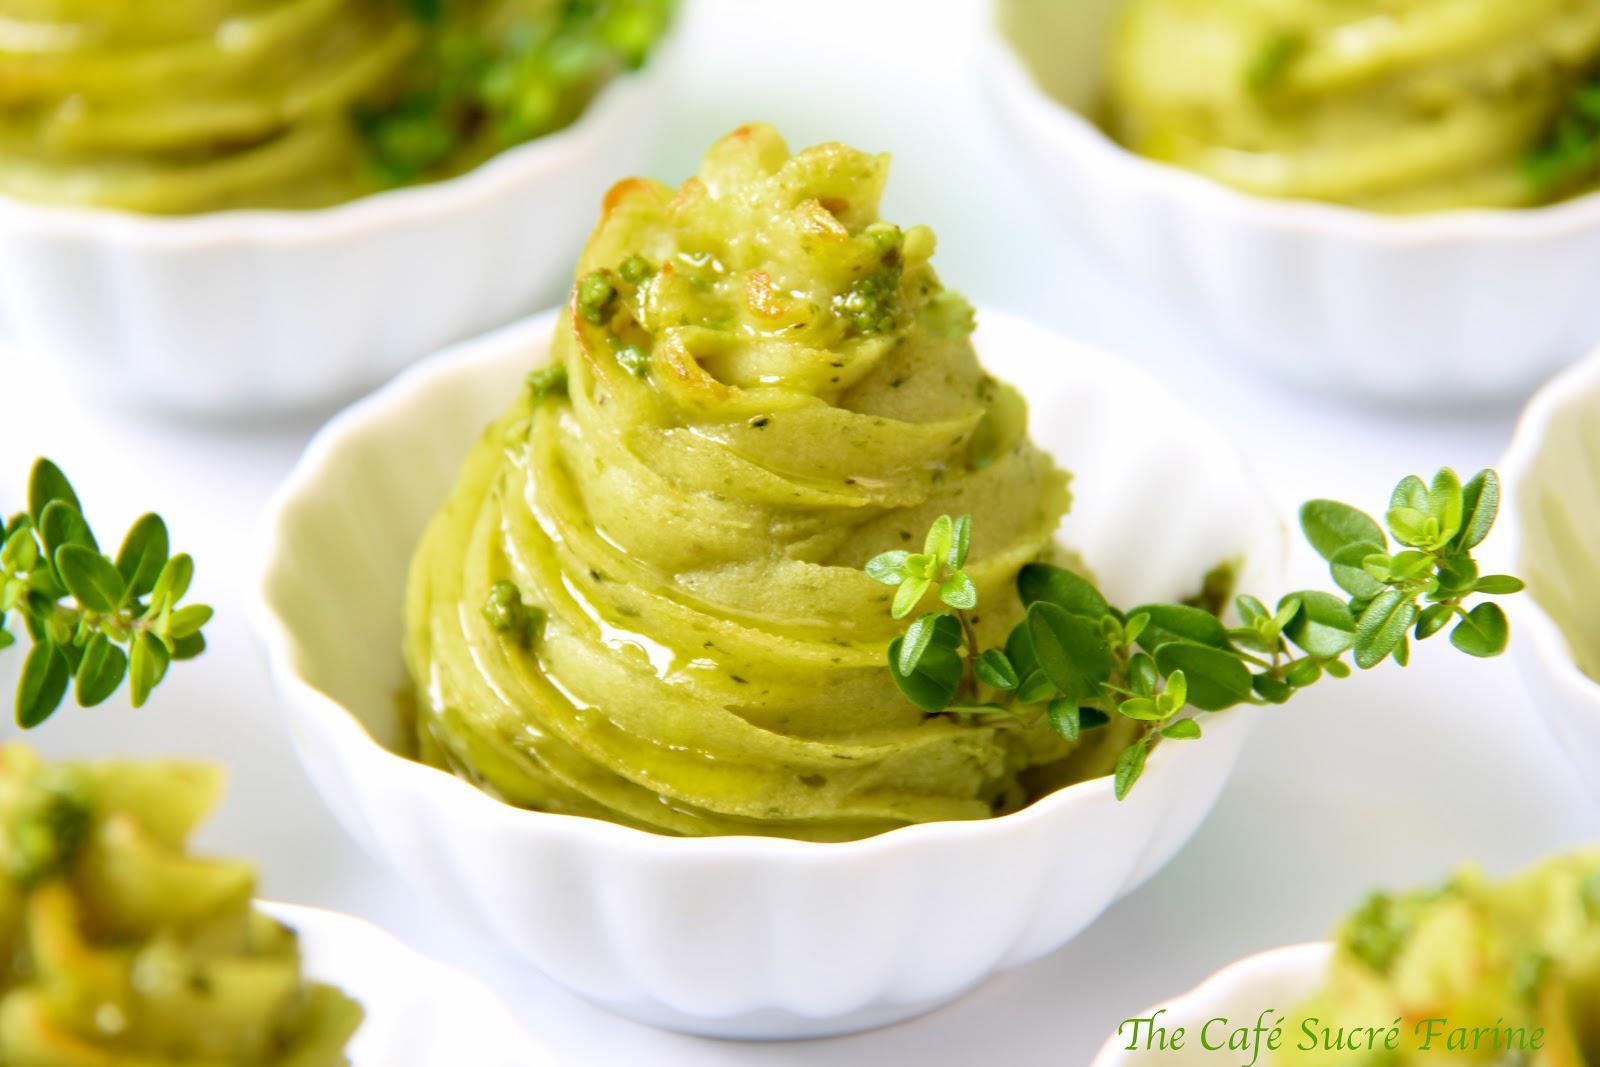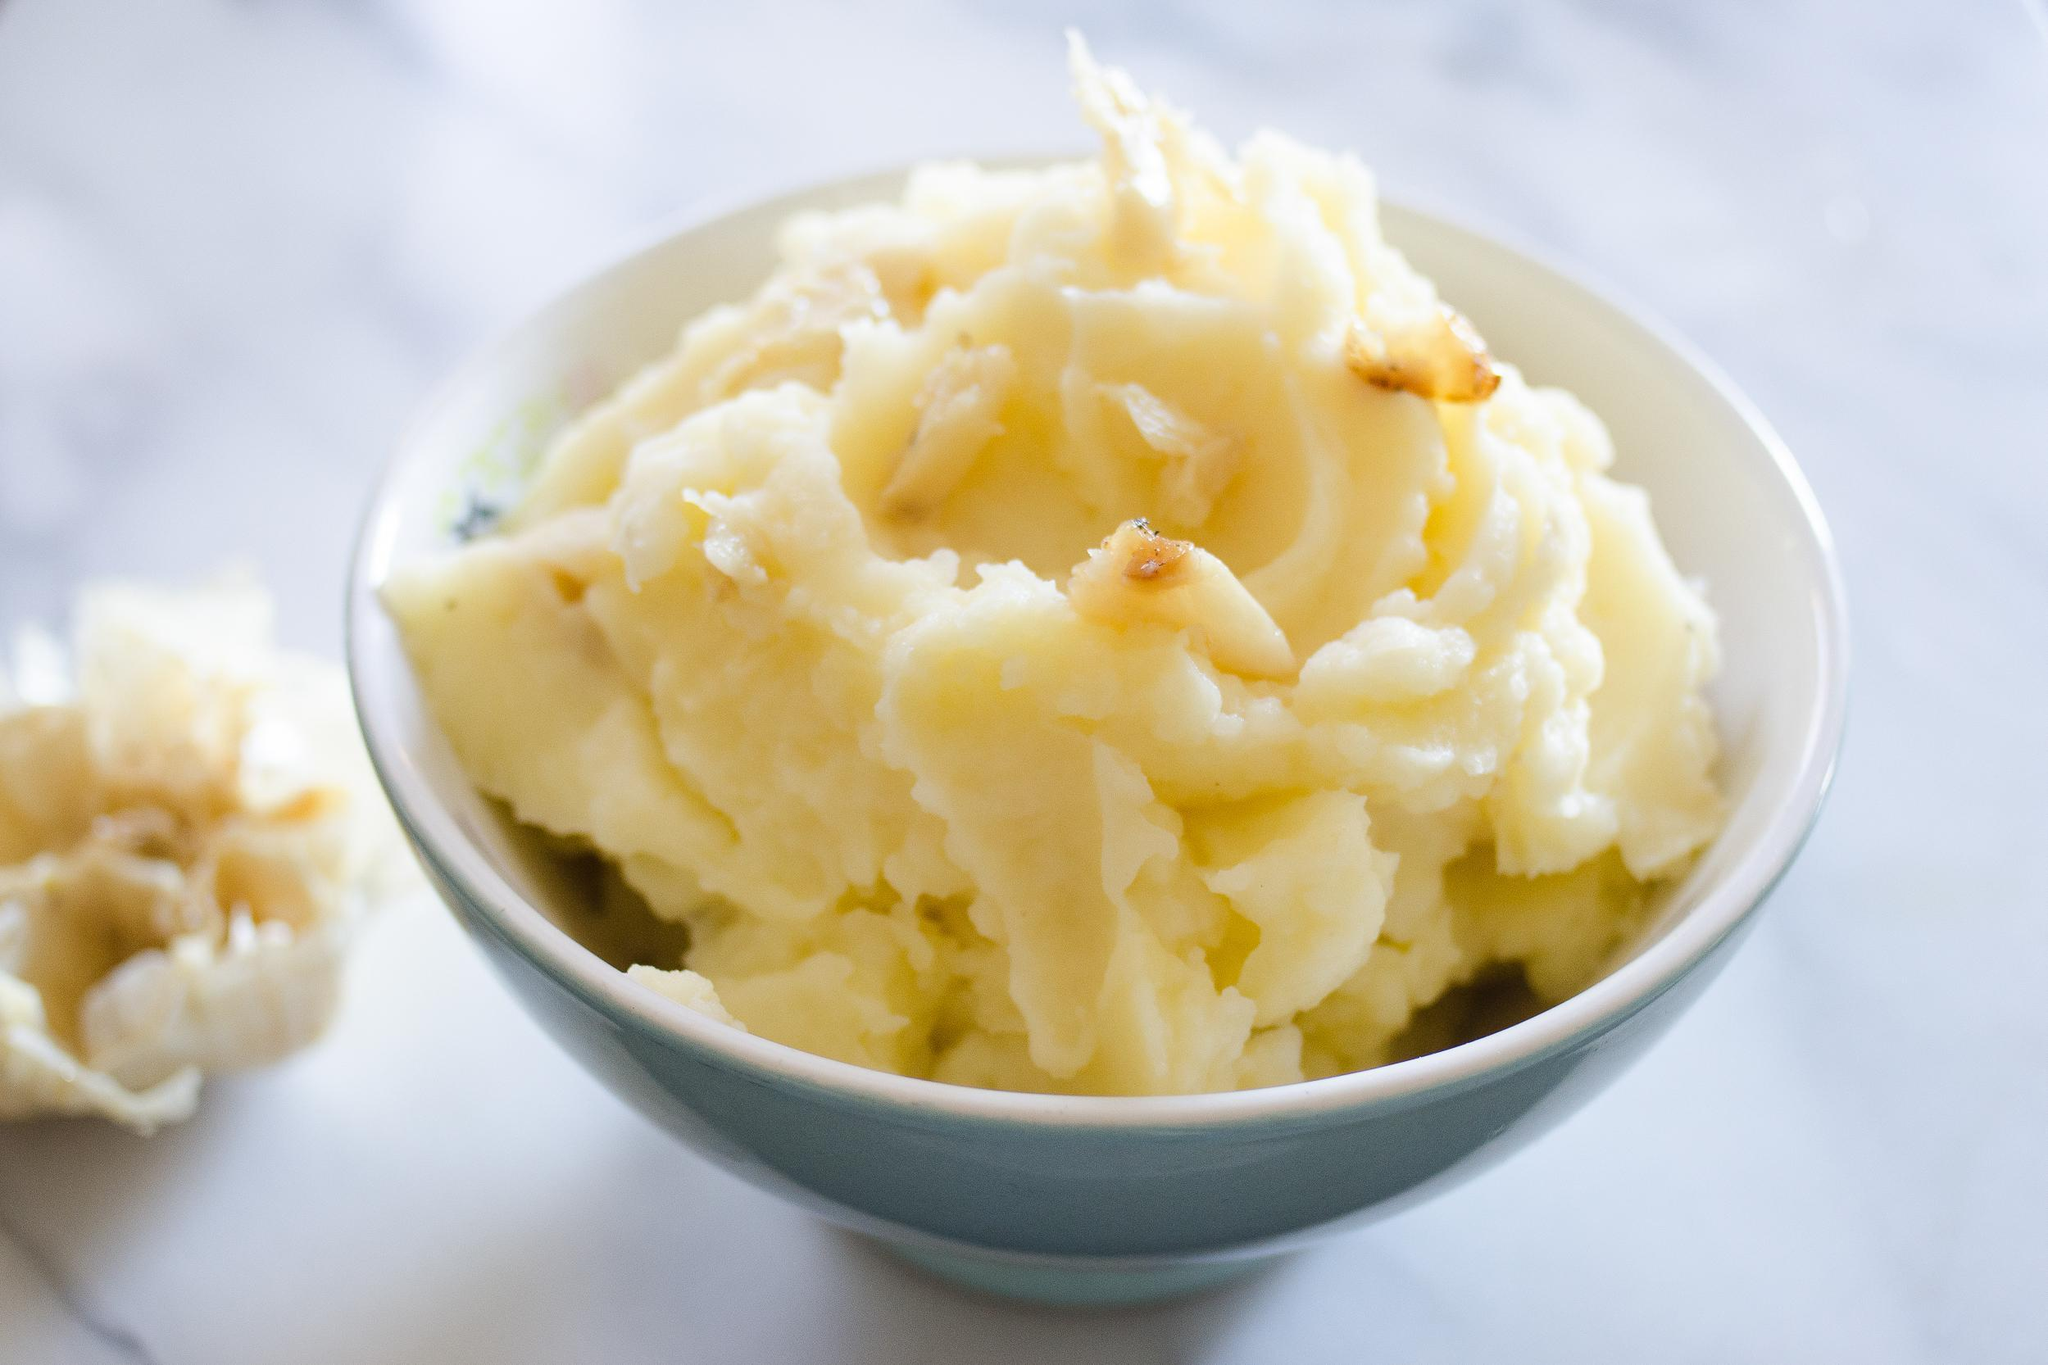The first image is the image on the left, the second image is the image on the right. For the images displayed, is the sentence "The right image contains food inside of a bowl." factually correct? Answer yes or no. Yes. The first image is the image on the left, the second image is the image on the right. For the images shown, is this caption "At least one of the mashed potatoes is not the traditional yellow/orange color." true? Answer yes or no. Yes. 